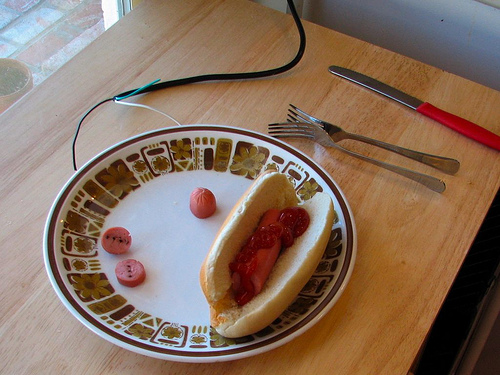<image>What toppings are on the dish? I am not sure what toppings are on the dish. It could be ketchup. What toppings are on the dish? The dish is topped with ketchup. 